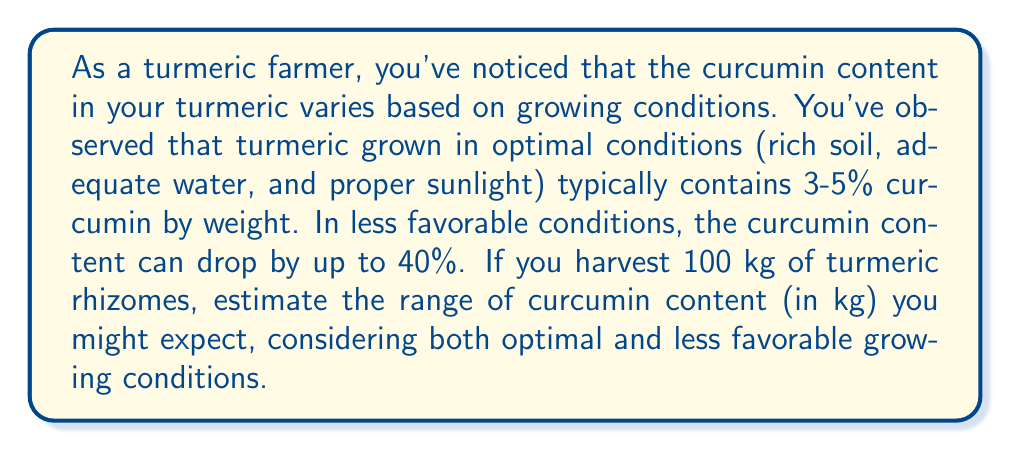What is the answer to this math problem? Let's approach this problem step by step:

1. First, let's calculate the range of curcumin content under optimal conditions:
   - Minimum: $100 \text{ kg} \times 3\% = 100 \times 0.03 = 3 \text{ kg}$
   - Maximum: $100 \text{ kg} \times 5\% = 100 \times 0.05 = 5 \text{ kg}$

2. Now, let's consider the less favorable conditions:
   - The curcumin content can drop by up to 40%
   - This means the minimum curcumin content could be:
     $3 \text{ kg} \times (1 - 0.40) = 3 \times 0.60 = 1.8 \text{ kg}$

3. To summarize:
   - Minimum possible curcumin content: $1.8 \text{ kg}$
   - Maximum possible curcumin content: $5 \text{ kg}$

Therefore, the range of curcumin content can be expressed as the inequality:

$$1.8 \text{ kg} \leq \text{curcumin content} \leq 5 \text{ kg}$$
Answer: The estimated range of curcumin content in 100 kg of turmeric rhizomes, considering both optimal and less favorable growing conditions, is $1.8 \text{ kg} \leq \text{curcumin content} \leq 5 \text{ kg}$. 